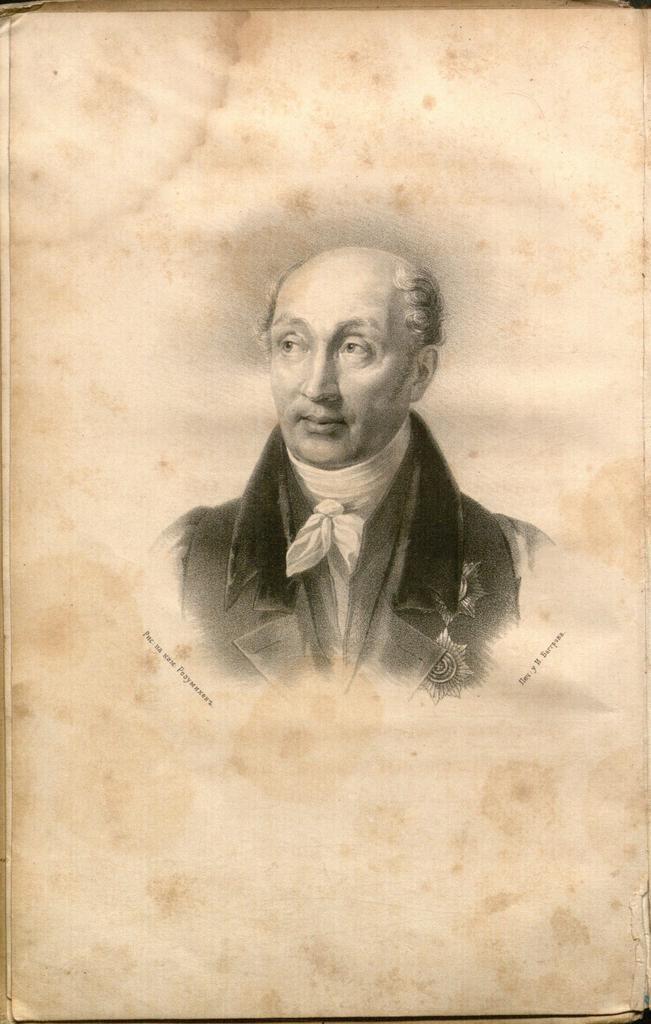How would you summarize this image in a sentence or two? This image consists of a paper with an image of a man. 